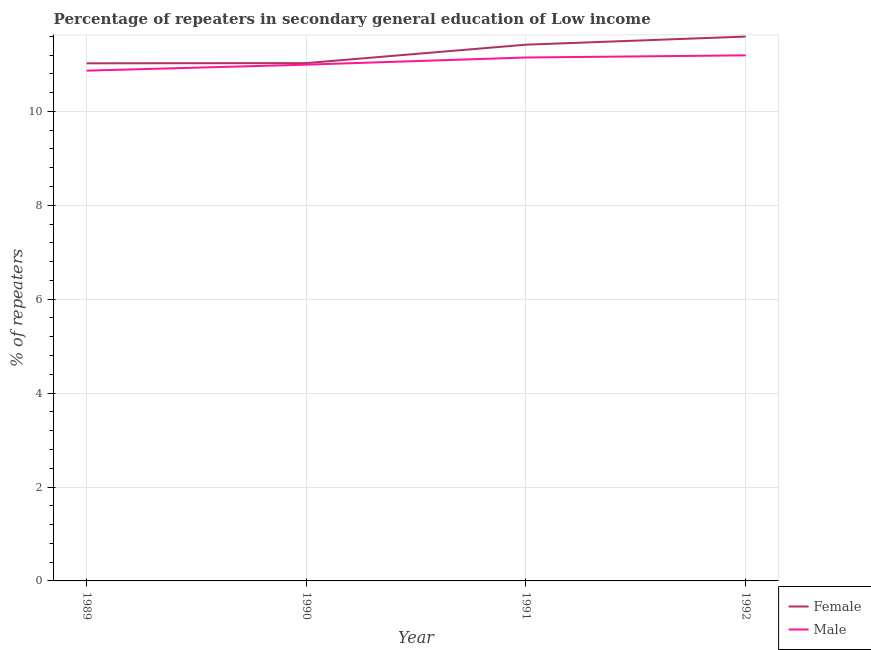How many different coloured lines are there?
Provide a succinct answer. 2. What is the percentage of female repeaters in 1990?
Offer a very short reply. 11.03. Across all years, what is the maximum percentage of male repeaters?
Offer a very short reply. 11.19. Across all years, what is the minimum percentage of female repeaters?
Keep it short and to the point. 11.02. What is the total percentage of female repeaters in the graph?
Keep it short and to the point. 45.07. What is the difference between the percentage of male repeaters in 1989 and that in 1990?
Offer a very short reply. -0.13. What is the difference between the percentage of female repeaters in 1989 and the percentage of male repeaters in 1992?
Your answer should be compact. -0.17. What is the average percentage of female repeaters per year?
Provide a succinct answer. 11.27. In the year 1990, what is the difference between the percentage of male repeaters and percentage of female repeaters?
Make the answer very short. -0.03. What is the ratio of the percentage of female repeaters in 1989 to that in 1991?
Provide a succinct answer. 0.97. Is the percentage of male repeaters in 1990 less than that in 1991?
Your response must be concise. Yes. Is the difference between the percentage of female repeaters in 1989 and 1991 greater than the difference between the percentage of male repeaters in 1989 and 1991?
Provide a succinct answer. No. What is the difference between the highest and the second highest percentage of male repeaters?
Your answer should be very brief. 0.05. What is the difference between the highest and the lowest percentage of male repeaters?
Keep it short and to the point. 0.33. Is the sum of the percentage of female repeaters in 1989 and 1991 greater than the maximum percentage of male repeaters across all years?
Offer a terse response. Yes. Is the percentage of female repeaters strictly greater than the percentage of male repeaters over the years?
Give a very brief answer. Yes. Is the percentage of male repeaters strictly less than the percentage of female repeaters over the years?
Your answer should be compact. Yes. How many lines are there?
Your answer should be very brief. 2. What is the difference between two consecutive major ticks on the Y-axis?
Your response must be concise. 2. Does the graph contain any zero values?
Offer a very short reply. No. How are the legend labels stacked?
Provide a short and direct response. Vertical. What is the title of the graph?
Provide a short and direct response. Percentage of repeaters in secondary general education of Low income. What is the label or title of the Y-axis?
Provide a succinct answer. % of repeaters. What is the % of repeaters in Female in 1989?
Keep it short and to the point. 11.02. What is the % of repeaters of Male in 1989?
Your answer should be compact. 10.87. What is the % of repeaters in Female in 1990?
Your response must be concise. 11.03. What is the % of repeaters in Male in 1990?
Provide a succinct answer. 11. What is the % of repeaters in Female in 1991?
Offer a very short reply. 11.42. What is the % of repeaters of Male in 1991?
Your answer should be very brief. 11.15. What is the % of repeaters in Female in 1992?
Keep it short and to the point. 11.59. What is the % of repeaters of Male in 1992?
Provide a succinct answer. 11.19. Across all years, what is the maximum % of repeaters of Female?
Provide a succinct answer. 11.59. Across all years, what is the maximum % of repeaters in Male?
Your answer should be very brief. 11.19. Across all years, what is the minimum % of repeaters in Female?
Give a very brief answer. 11.02. Across all years, what is the minimum % of repeaters in Male?
Provide a short and direct response. 10.87. What is the total % of repeaters of Female in the graph?
Give a very brief answer. 45.07. What is the total % of repeaters in Male in the graph?
Make the answer very short. 44.21. What is the difference between the % of repeaters in Female in 1989 and that in 1990?
Your answer should be very brief. -0. What is the difference between the % of repeaters of Male in 1989 and that in 1990?
Provide a short and direct response. -0.13. What is the difference between the % of repeaters in Female in 1989 and that in 1991?
Your answer should be very brief. -0.4. What is the difference between the % of repeaters of Male in 1989 and that in 1991?
Give a very brief answer. -0.28. What is the difference between the % of repeaters of Female in 1989 and that in 1992?
Provide a short and direct response. -0.57. What is the difference between the % of repeaters in Male in 1989 and that in 1992?
Keep it short and to the point. -0.33. What is the difference between the % of repeaters in Female in 1990 and that in 1991?
Your response must be concise. -0.39. What is the difference between the % of repeaters of Male in 1990 and that in 1991?
Offer a terse response. -0.15. What is the difference between the % of repeaters in Female in 1990 and that in 1992?
Give a very brief answer. -0.56. What is the difference between the % of repeaters of Male in 1990 and that in 1992?
Ensure brevity in your answer.  -0.2. What is the difference between the % of repeaters in Female in 1991 and that in 1992?
Give a very brief answer. -0.17. What is the difference between the % of repeaters of Male in 1991 and that in 1992?
Your answer should be very brief. -0.05. What is the difference between the % of repeaters of Female in 1989 and the % of repeaters of Male in 1990?
Your response must be concise. 0.03. What is the difference between the % of repeaters in Female in 1989 and the % of repeaters in Male in 1991?
Give a very brief answer. -0.12. What is the difference between the % of repeaters of Female in 1989 and the % of repeaters of Male in 1992?
Your answer should be very brief. -0.17. What is the difference between the % of repeaters of Female in 1990 and the % of repeaters of Male in 1991?
Keep it short and to the point. -0.12. What is the difference between the % of repeaters of Female in 1990 and the % of repeaters of Male in 1992?
Make the answer very short. -0.17. What is the difference between the % of repeaters of Female in 1991 and the % of repeaters of Male in 1992?
Offer a terse response. 0.23. What is the average % of repeaters in Female per year?
Your response must be concise. 11.27. What is the average % of repeaters in Male per year?
Your response must be concise. 11.05. In the year 1989, what is the difference between the % of repeaters of Female and % of repeaters of Male?
Provide a succinct answer. 0.16. In the year 1990, what is the difference between the % of repeaters in Female and % of repeaters in Male?
Make the answer very short. 0.03. In the year 1991, what is the difference between the % of repeaters in Female and % of repeaters in Male?
Your answer should be very brief. 0.27. In the year 1992, what is the difference between the % of repeaters of Female and % of repeaters of Male?
Ensure brevity in your answer.  0.4. What is the ratio of the % of repeaters of Male in 1989 to that in 1990?
Your answer should be very brief. 0.99. What is the ratio of the % of repeaters in Female in 1989 to that in 1991?
Provide a succinct answer. 0.97. What is the ratio of the % of repeaters of Male in 1989 to that in 1991?
Make the answer very short. 0.97. What is the ratio of the % of repeaters of Female in 1989 to that in 1992?
Offer a terse response. 0.95. What is the ratio of the % of repeaters of Male in 1989 to that in 1992?
Offer a terse response. 0.97. What is the ratio of the % of repeaters of Female in 1990 to that in 1991?
Your answer should be compact. 0.97. What is the ratio of the % of repeaters of Male in 1990 to that in 1991?
Your answer should be very brief. 0.99. What is the ratio of the % of repeaters of Female in 1990 to that in 1992?
Your answer should be very brief. 0.95. What is the ratio of the % of repeaters in Male in 1990 to that in 1992?
Offer a terse response. 0.98. What is the ratio of the % of repeaters in Female in 1991 to that in 1992?
Ensure brevity in your answer.  0.99. What is the ratio of the % of repeaters in Male in 1991 to that in 1992?
Give a very brief answer. 1. What is the difference between the highest and the second highest % of repeaters in Female?
Provide a succinct answer. 0.17. What is the difference between the highest and the second highest % of repeaters of Male?
Give a very brief answer. 0.05. What is the difference between the highest and the lowest % of repeaters of Female?
Provide a succinct answer. 0.57. What is the difference between the highest and the lowest % of repeaters of Male?
Offer a terse response. 0.33. 